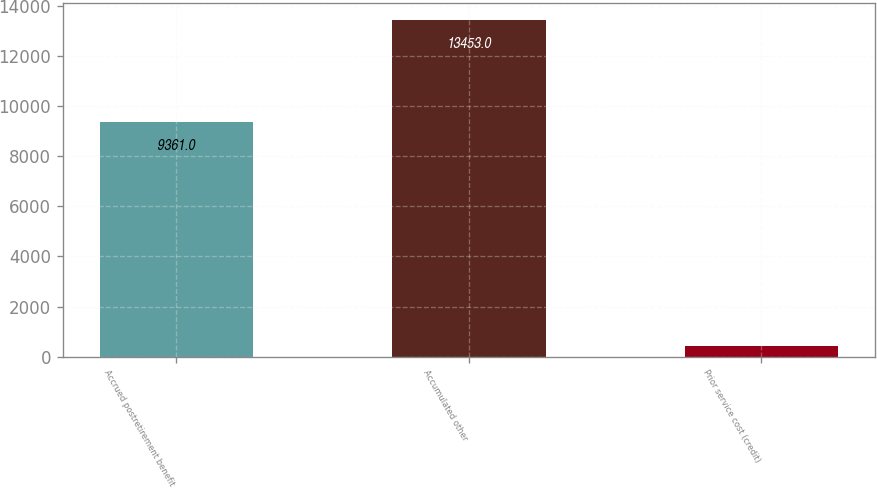Convert chart. <chart><loc_0><loc_0><loc_500><loc_500><bar_chart><fcel>Accrued postretirement benefit<fcel>Accumulated other<fcel>Prior service cost (credit)<nl><fcel>9361<fcel>13453<fcel>443<nl></chart> 